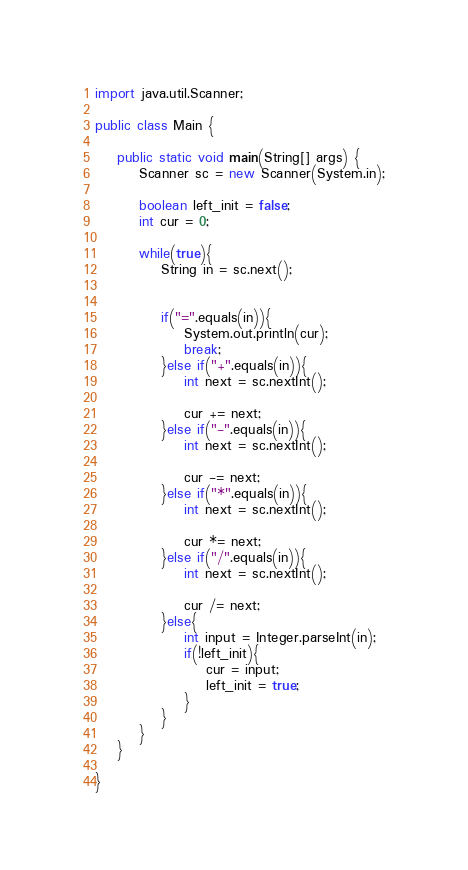Convert code to text. <code><loc_0><loc_0><loc_500><loc_500><_Java_>import java.util.Scanner;

public class Main {

	public static void main(String[] args) {
		Scanner sc = new Scanner(System.in);

		boolean left_init = false;
		int cur = 0;

		while(true){
			String in = sc.next();


			if("=".equals(in)){
				System.out.println(cur);
				break;
			}else if("+".equals(in)){
				int next = sc.nextInt();

				cur += next;
			}else if("-".equals(in)){
				int next = sc.nextInt();

				cur -= next;
			}else if("*".equals(in)){
				int next = sc.nextInt();

				cur *= next;
			}else if("/".equals(in)){
				int next = sc.nextInt();

				cur /= next;
			}else{
				int input = Integer.parseInt(in);
				if(!left_init){
					cur = input;
					left_init = true;
				}
			}
		}
	}

}

</code> 